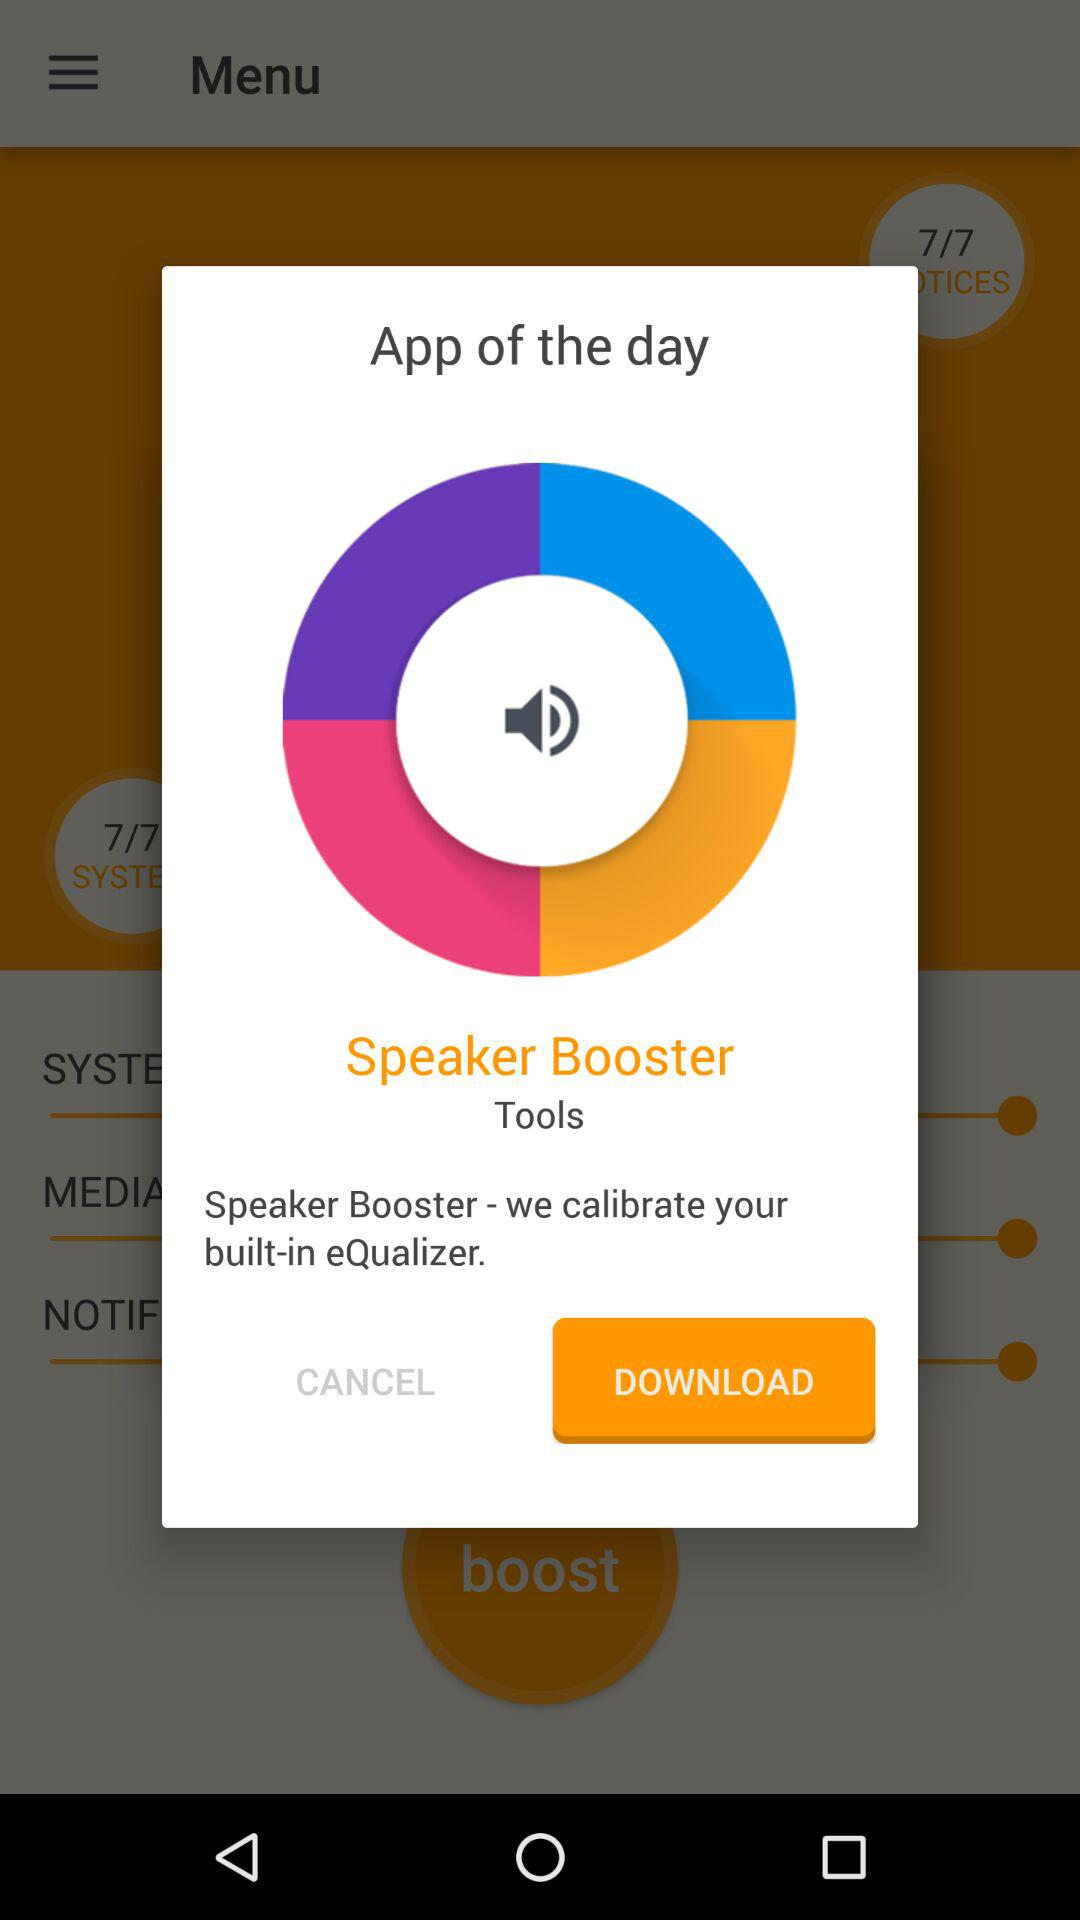Which option is selected for the application?
When the provided information is insufficient, respond with <no answer>. <no answer> 